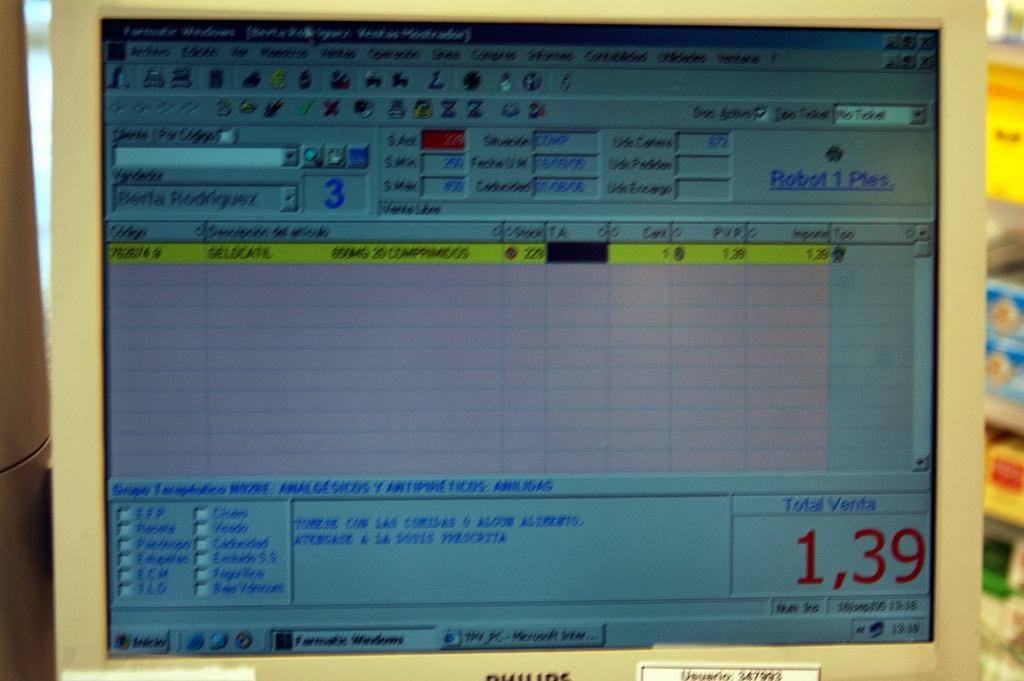What number is written in big red letters in the corner?
Offer a very short reply. 1,39. What does the red number mean?
Provide a succinct answer. Total venta. 